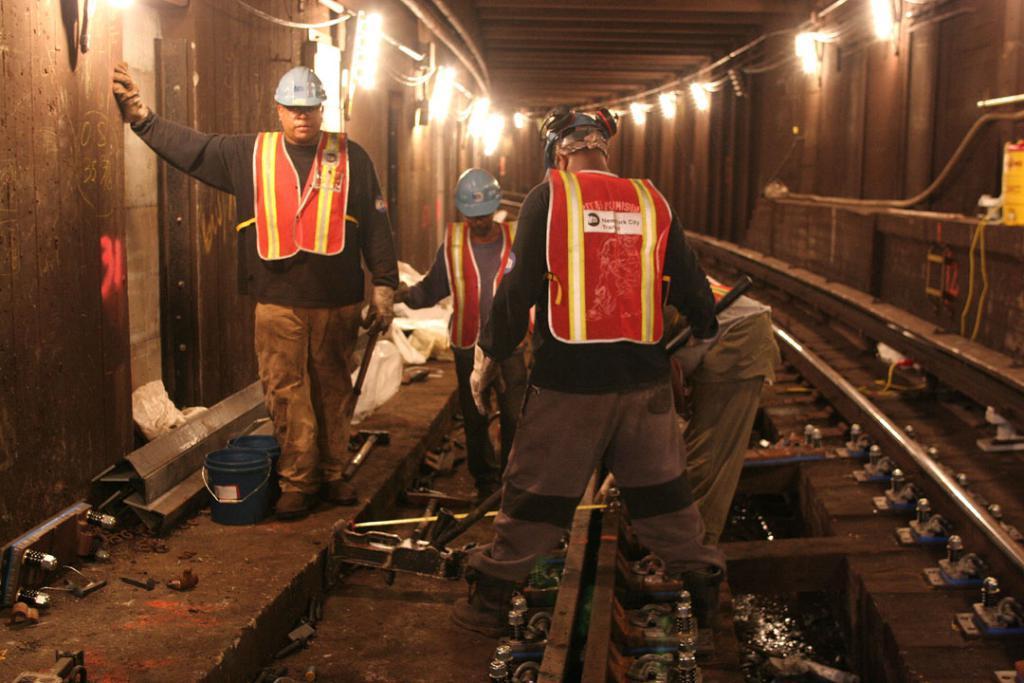Can you describe this image briefly? In this picture we can see there are four people standing. In front of the people, it looks like the railway track. On the left side of the people there are two plastic containers, hammer and other tools. On the left and right side of the people, those are looking like the walls and on the walls there are lights, pipes and cables. 